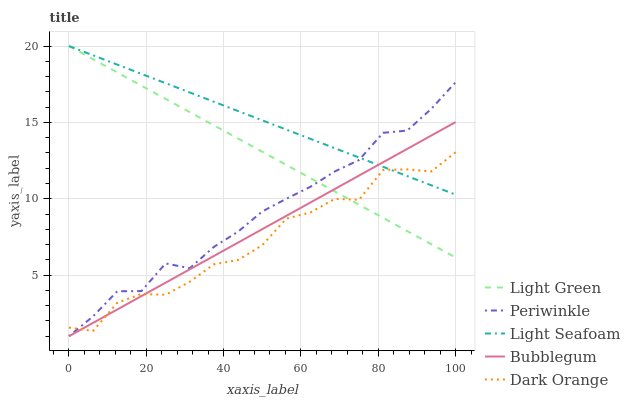Does Dark Orange have the minimum area under the curve?
Answer yes or no. Yes. Does Light Seafoam have the maximum area under the curve?
Answer yes or no. Yes. Does Periwinkle have the minimum area under the curve?
Answer yes or no. No. Does Periwinkle have the maximum area under the curve?
Answer yes or no. No. Is Bubblegum the smoothest?
Answer yes or no. Yes. Is Dark Orange the roughest?
Answer yes or no. Yes. Is Light Seafoam the smoothest?
Answer yes or no. No. Is Light Seafoam the roughest?
Answer yes or no. No. Does Periwinkle have the lowest value?
Answer yes or no. Yes. Does Light Seafoam have the lowest value?
Answer yes or no. No. Does Light Green have the highest value?
Answer yes or no. Yes. Does Periwinkle have the highest value?
Answer yes or no. No. Does Light Green intersect Periwinkle?
Answer yes or no. Yes. Is Light Green less than Periwinkle?
Answer yes or no. No. Is Light Green greater than Periwinkle?
Answer yes or no. No. 